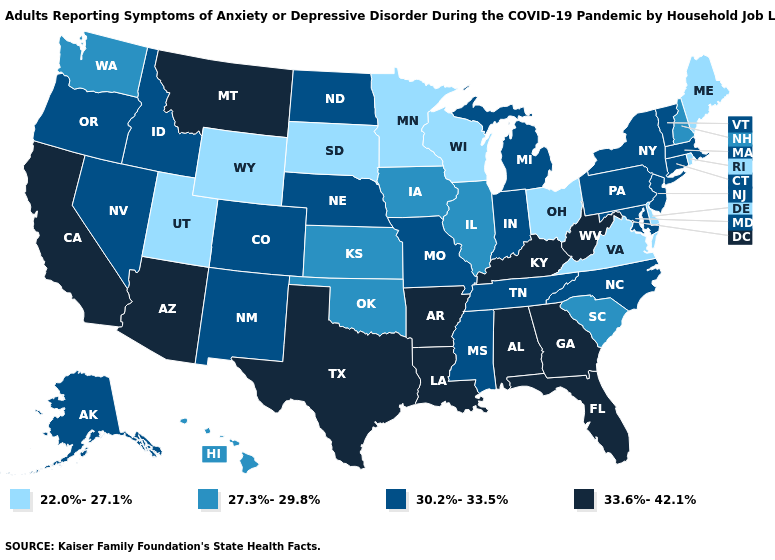How many symbols are there in the legend?
Be succinct. 4. Does the map have missing data?
Give a very brief answer. No. Among the states that border West Virginia , which have the lowest value?
Write a very short answer. Ohio, Virginia. Name the states that have a value in the range 22.0%-27.1%?
Write a very short answer. Delaware, Maine, Minnesota, Ohio, Rhode Island, South Dakota, Utah, Virginia, Wisconsin, Wyoming. What is the value of Texas?
Concise answer only. 33.6%-42.1%. Does the first symbol in the legend represent the smallest category?
Write a very short answer. Yes. Which states have the lowest value in the Northeast?
Concise answer only. Maine, Rhode Island. Name the states that have a value in the range 33.6%-42.1%?
Be succinct. Alabama, Arizona, Arkansas, California, Florida, Georgia, Kentucky, Louisiana, Montana, Texas, West Virginia. Name the states that have a value in the range 30.2%-33.5%?
Answer briefly. Alaska, Colorado, Connecticut, Idaho, Indiana, Maryland, Massachusetts, Michigan, Mississippi, Missouri, Nebraska, Nevada, New Jersey, New Mexico, New York, North Carolina, North Dakota, Oregon, Pennsylvania, Tennessee, Vermont. Among the states that border Minnesota , does Wisconsin have the lowest value?
Keep it brief. Yes. Which states hav the highest value in the Northeast?
Quick response, please. Connecticut, Massachusetts, New Jersey, New York, Pennsylvania, Vermont. Name the states that have a value in the range 30.2%-33.5%?
Write a very short answer. Alaska, Colorado, Connecticut, Idaho, Indiana, Maryland, Massachusetts, Michigan, Mississippi, Missouri, Nebraska, Nevada, New Jersey, New Mexico, New York, North Carolina, North Dakota, Oregon, Pennsylvania, Tennessee, Vermont. Does Nebraska have the highest value in the USA?
Quick response, please. No. Does Connecticut have a higher value than Idaho?
Concise answer only. No. Does the first symbol in the legend represent the smallest category?
Write a very short answer. Yes. 